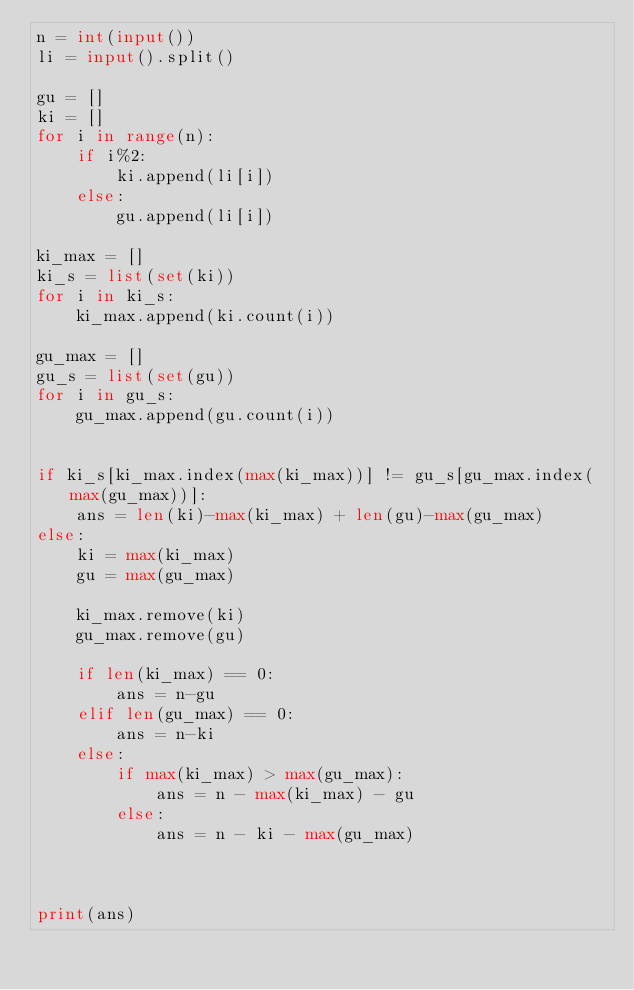Convert code to text. <code><loc_0><loc_0><loc_500><loc_500><_Python_>n = int(input())
li = input().split()

gu = []
ki = []
for i in range(n):
    if i%2:
        ki.append(li[i])
    else:
        gu.append(li[i])

ki_max = []
ki_s = list(set(ki))
for i in ki_s:
    ki_max.append(ki.count(i))

gu_max = []
gu_s = list(set(gu))
for i in gu_s:
    gu_max.append(gu.count(i))


if ki_s[ki_max.index(max(ki_max))] != gu_s[gu_max.index(max(gu_max))]:
    ans = len(ki)-max(ki_max) + len(gu)-max(gu_max)
else:
    ki = max(ki_max)
    gu = max(gu_max)

    ki_max.remove(ki)
    gu_max.remove(gu)

    if len(ki_max) == 0:
        ans = n-gu
    elif len(gu_max) == 0:
        ans = n-ki
    else:
        if max(ki_max) > max(gu_max):
            ans = n - max(ki_max) - gu
        else:
            ans = n - ki - max(gu_max)



print(ans)
</code> 